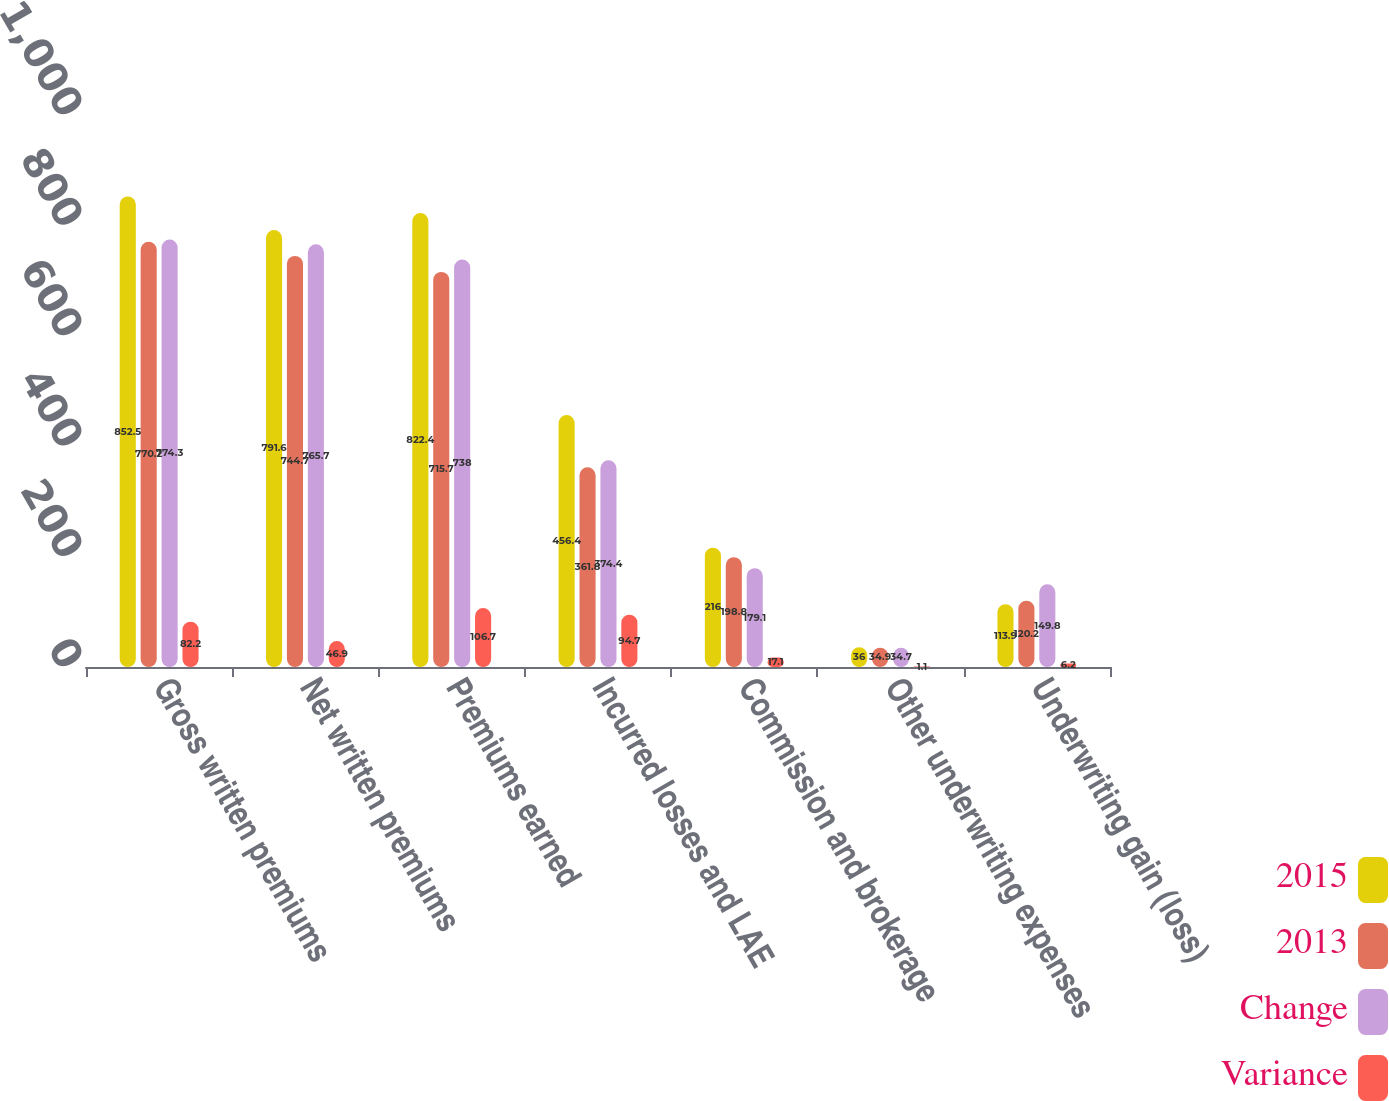Convert chart. <chart><loc_0><loc_0><loc_500><loc_500><stacked_bar_chart><ecel><fcel>Gross written premiums<fcel>Net written premiums<fcel>Premiums earned<fcel>Incurred losses and LAE<fcel>Commission and brokerage<fcel>Other underwriting expenses<fcel>Underwriting gain (loss)<nl><fcel>2015<fcel>852.5<fcel>791.6<fcel>822.4<fcel>456.4<fcel>216<fcel>36<fcel>113.9<nl><fcel>2013<fcel>770.2<fcel>744.7<fcel>715.7<fcel>361.8<fcel>198.8<fcel>34.9<fcel>120.2<nl><fcel>Change<fcel>774.3<fcel>765.7<fcel>738<fcel>374.4<fcel>179.1<fcel>34.7<fcel>149.8<nl><fcel>Variance<fcel>82.2<fcel>46.9<fcel>106.7<fcel>94.7<fcel>17.1<fcel>1.1<fcel>6.2<nl></chart> 